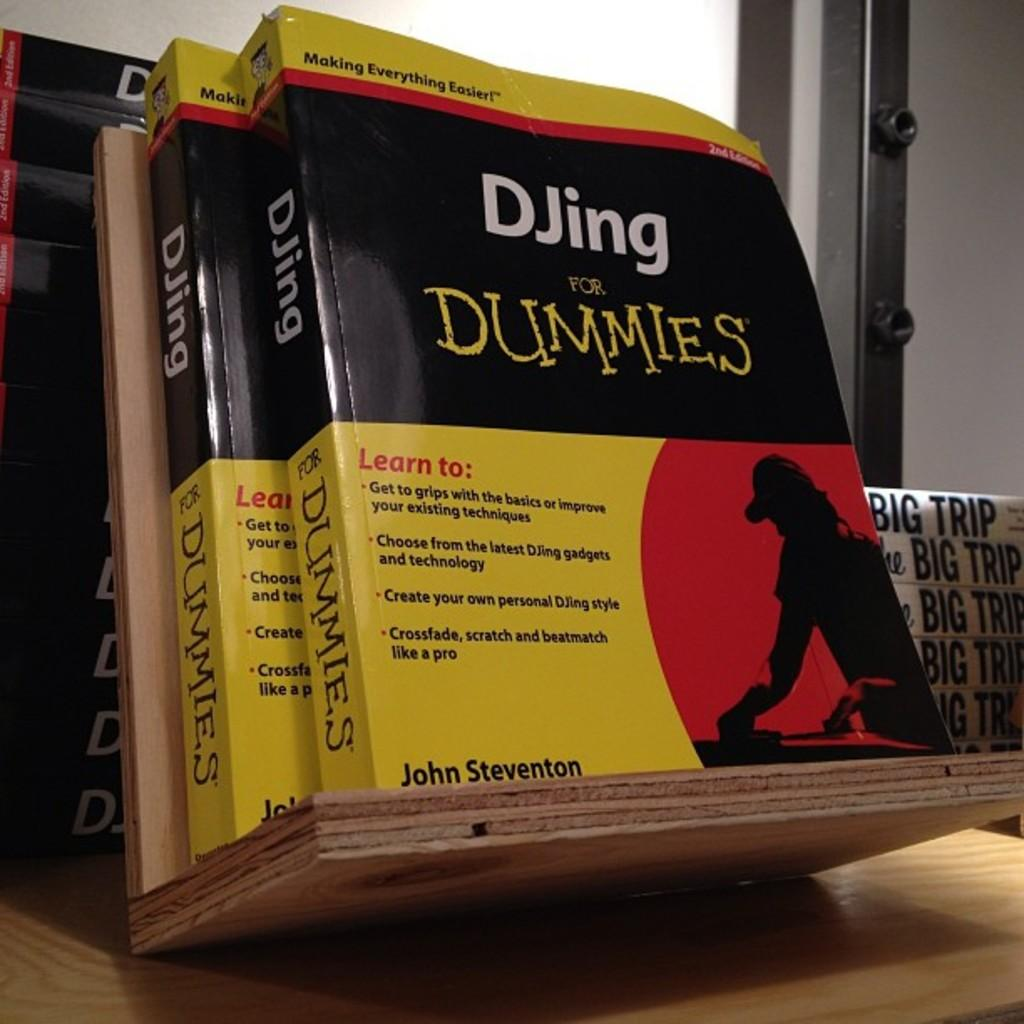<image>
Describe the image concisely. A shelf with books about Djing for Dummies 